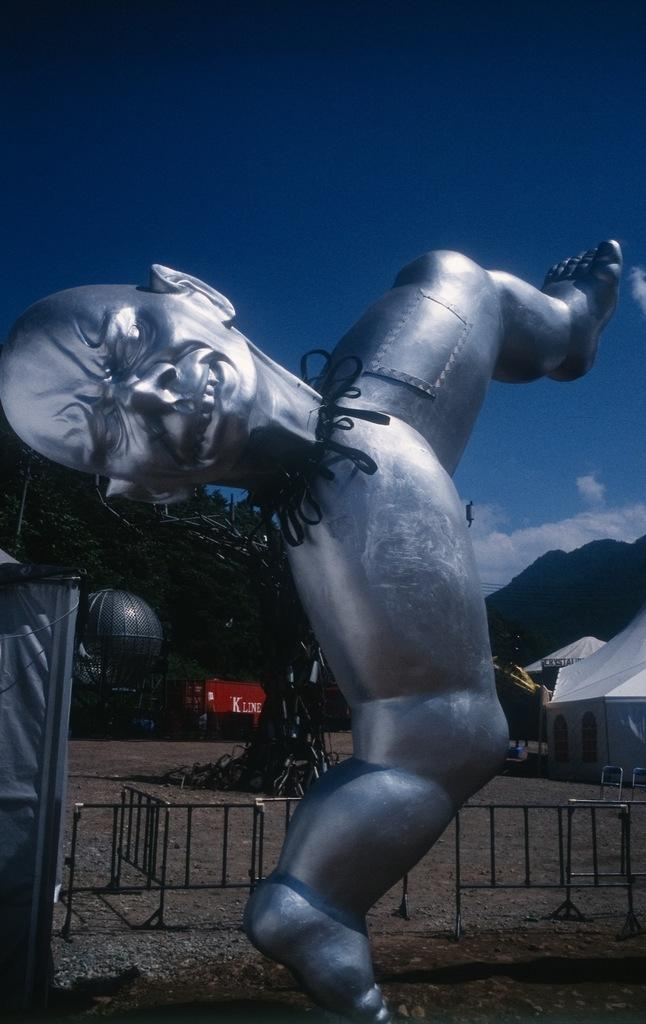What is the main subject in the center of the image? There is a statue in the center of the image. What is located behind the statue? There is a boundary behind the statue. What can be seen in the background of the image? There are tents and trees in the background of the image. What type of grass is being offered to the statue in the image? There is no grass or offering present in the image; it only features a statue, a boundary, and tents and trees in the background. 